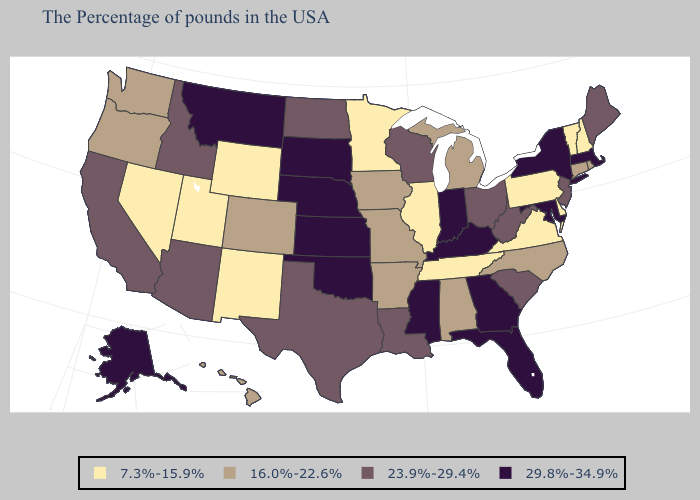What is the highest value in states that border North Dakota?
Give a very brief answer. 29.8%-34.9%. How many symbols are there in the legend?
Give a very brief answer. 4. Among the states that border Kentucky , which have the lowest value?
Keep it brief. Virginia, Tennessee, Illinois. Which states have the lowest value in the MidWest?
Concise answer only. Illinois, Minnesota. Does Oklahoma have a lower value than New York?
Write a very short answer. No. Name the states that have a value in the range 16.0%-22.6%?
Be succinct. Rhode Island, Connecticut, North Carolina, Michigan, Alabama, Missouri, Arkansas, Iowa, Colorado, Washington, Oregon, Hawaii. Name the states that have a value in the range 7.3%-15.9%?
Quick response, please. New Hampshire, Vermont, Delaware, Pennsylvania, Virginia, Tennessee, Illinois, Minnesota, Wyoming, New Mexico, Utah, Nevada. Among the states that border South Dakota , which have the lowest value?
Write a very short answer. Minnesota, Wyoming. Which states have the highest value in the USA?
Short answer required. Massachusetts, New York, Maryland, Florida, Georgia, Kentucky, Indiana, Mississippi, Kansas, Nebraska, Oklahoma, South Dakota, Montana, Alaska. Among the states that border Virginia , does Maryland have the lowest value?
Keep it brief. No. Among the states that border Washington , does Oregon have the highest value?
Be succinct. No. What is the value of Connecticut?
Keep it brief. 16.0%-22.6%. Name the states that have a value in the range 7.3%-15.9%?
Concise answer only. New Hampshire, Vermont, Delaware, Pennsylvania, Virginia, Tennessee, Illinois, Minnesota, Wyoming, New Mexico, Utah, Nevada. What is the value of Minnesota?
Answer briefly. 7.3%-15.9%. Does North Dakota have a higher value than South Carolina?
Quick response, please. No. 